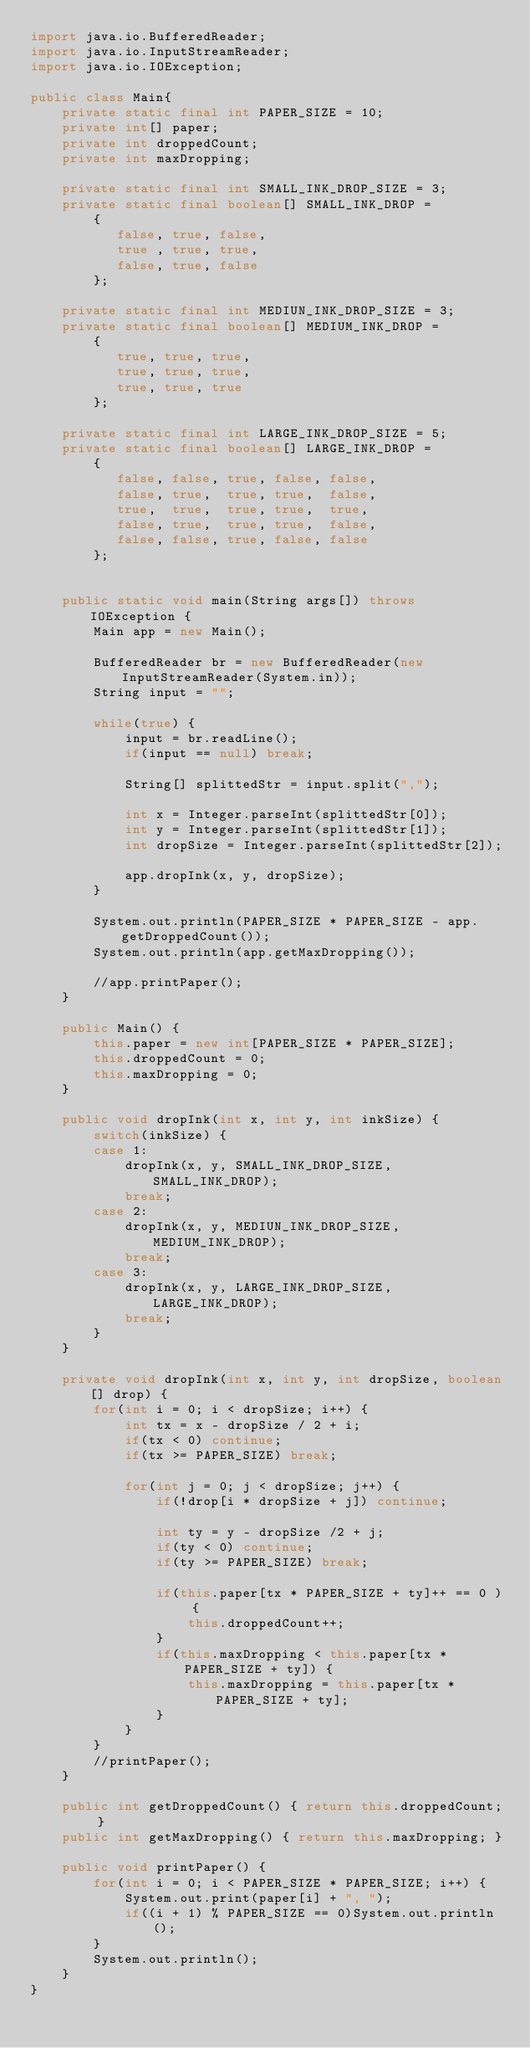<code> <loc_0><loc_0><loc_500><loc_500><_Java_>import java.io.BufferedReader;
import java.io.InputStreamReader;
import java.io.IOException;

public class Main{
    private static final int PAPER_SIZE = 10;
    private int[] paper;
    private int droppedCount;
    private int maxDropping;
    
    private static final int SMALL_INK_DROP_SIZE = 3;
    private static final boolean[] SMALL_INK_DROP =
        {
           false, true, false,
           true , true, true,
           false, true, false
        };
    
    private static final int MEDIUN_INK_DROP_SIZE = 3;
    private static final boolean[] MEDIUM_INK_DROP =
        {
           true, true, true,
           true, true, true,
           true, true, true
        };
        
    private static final int LARGE_INK_DROP_SIZE = 5;
    private static final boolean[] LARGE_INK_DROP =
        {
           false, false, true, false, false,
           false, true,  true, true,  false,
           true,  true,  true, true,  true,
           false, true,  true, true,  false,
           false, false, true, false, false
        };
    
    
    public static void main(String args[]) throws IOException {
        Main app = new Main();
        
        BufferedReader br = new BufferedReader(new InputStreamReader(System.in));
        String input = "";
        
        while(true) {
            input = br.readLine();
            if(input == null) break;
            
            String[] splittedStr = input.split(",");
            
            int x = Integer.parseInt(splittedStr[0]);
            int y = Integer.parseInt(splittedStr[1]);
            int dropSize = Integer.parseInt(splittedStr[2]);
            
            app.dropInk(x, y, dropSize);
        }
        
        System.out.println(PAPER_SIZE * PAPER_SIZE - app.getDroppedCount());
        System.out.println(app.getMaxDropping());
        
        //app.printPaper();
    }
    
    public Main() {
        this.paper = new int[PAPER_SIZE * PAPER_SIZE];
        this.droppedCount = 0;
        this.maxDropping = 0;
    }
    
    public void dropInk(int x, int y, int inkSize) {
        switch(inkSize) {
        case 1:
            dropInk(x, y, SMALL_INK_DROP_SIZE, SMALL_INK_DROP);
            break;
        case 2:
            dropInk(x, y, MEDIUN_INK_DROP_SIZE, MEDIUM_INK_DROP);
            break;
        case 3:
            dropInk(x, y, LARGE_INK_DROP_SIZE, LARGE_INK_DROP);
            break;
        }
    }
    
    private void dropInk(int x, int y, int dropSize, boolean[] drop) {
        for(int i = 0; i < dropSize; i++) {
            int tx = x - dropSize / 2 + i;
            if(tx < 0) continue;
            if(tx >= PAPER_SIZE) break;
            
            for(int j = 0; j < dropSize; j++) {
                if(!drop[i * dropSize + j]) continue;
                
                int ty = y - dropSize /2 + j;
                if(ty < 0) continue;
                if(ty >= PAPER_SIZE) break;
                
                if(this.paper[tx * PAPER_SIZE + ty]++ == 0 ) {
                    this.droppedCount++;
                }
                if(this.maxDropping < this.paper[tx * PAPER_SIZE + ty]) {
                    this.maxDropping = this.paper[tx * PAPER_SIZE + ty];
                }
            }
        }
        //printPaper();
    }

    public int getDroppedCount() { return this.droppedCount; }
    public int getMaxDropping() { return this.maxDropping; }
    
    public void printPaper() {
        for(int i = 0; i < PAPER_SIZE * PAPER_SIZE; i++) {
            System.out.print(paper[i] + ", ");
            if((i + 1) % PAPER_SIZE == 0)System.out.println();
        }
        System.out.println();
    }
}</code> 